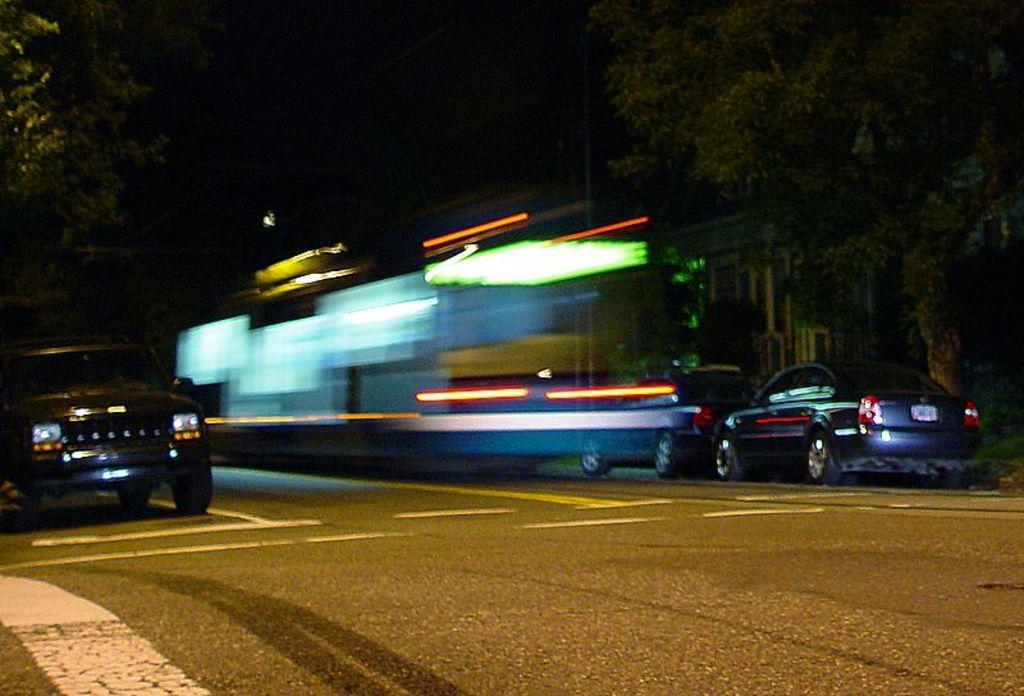What can be seen on the road in the image? There are cars parked on the road in the image. What is visible in the background of the image? There are trees, at least one building, and the sky visible in the background of the image. What type of cream can be seen dripping from the trees in the image? There is no cream present in the image; the trees are not depicted as having any cream on them. 